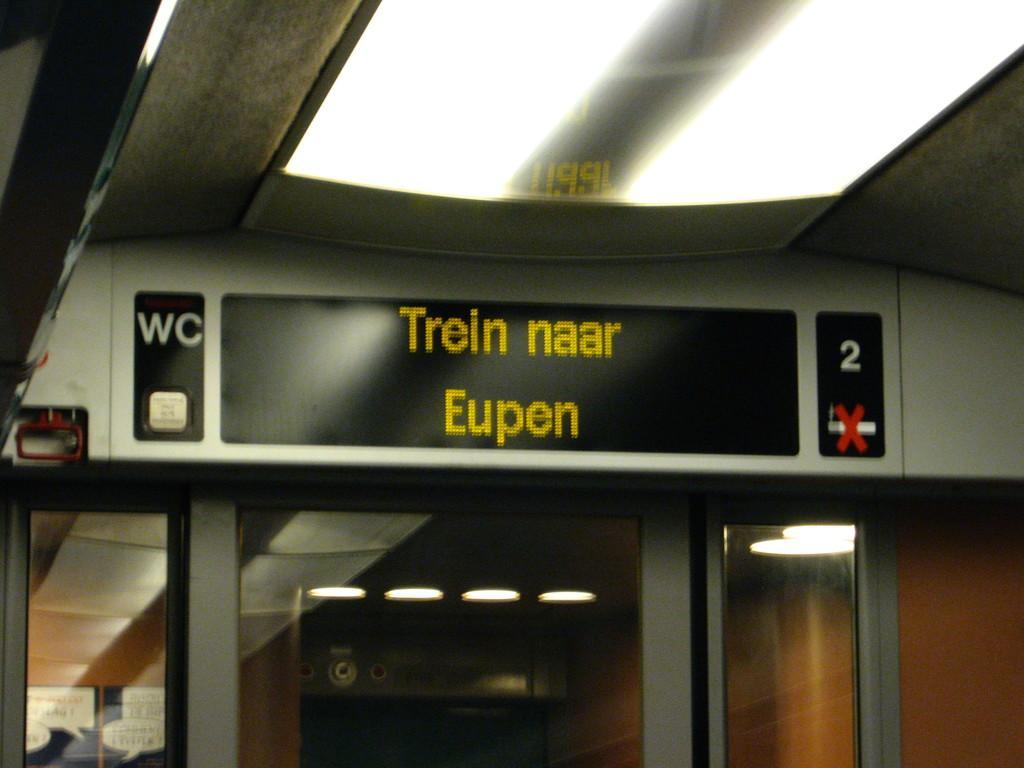Please provide a concise description of this image. In this image I can see number of lights, number of boards and on these words I can see something is written. I can also see glass wall like things on the bottom side. 